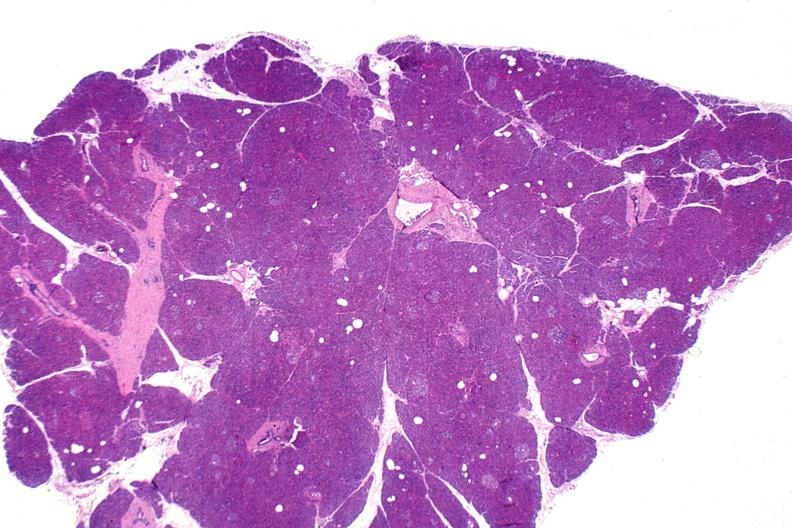does multiple myeloma show normal pancreas?
Answer the question using a single word or phrase. No 